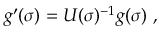<formula> <loc_0><loc_0><loc_500><loc_500>g ^ { \prime } ( \sigma ) = U ( \sigma ) ^ { - 1 } g ( \sigma ) ,</formula> 